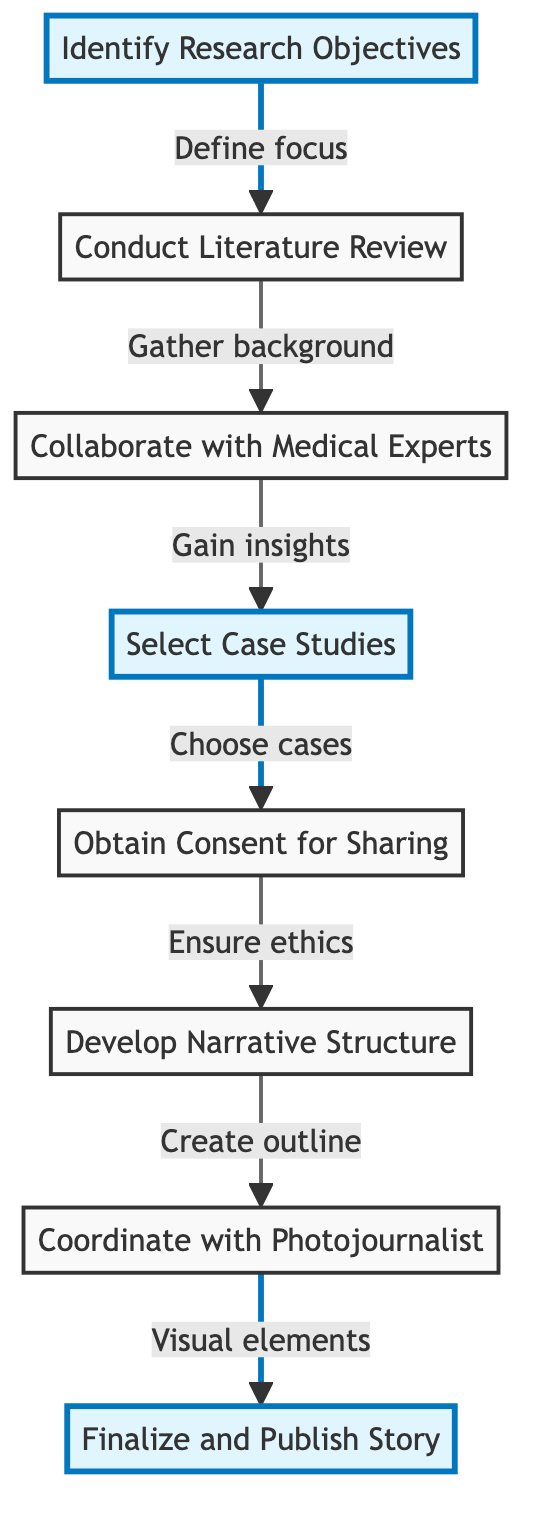What is the first step in the process? The first step in the process is "Identify Research Objectives," which is the starting point of the flowchart.
Answer: Identify Research Objectives How many nodes are highlighted in the diagram? There are three highlighted nodes in the diagram, which are "Identify Research Objectives," "Select Case Studies," and "Finalize and Publish Story."
Answer: Three What step follows after "Conduct Literature Review"? After "Conduct Literature Review," the next step is "Collaborate with Medical Experts," which illustrates the flow from reviewing literature to seeking expert insights.
Answer: Collaborate with Medical Experts What is required after selecting case studies? After selecting case studies, the next requirement is to "Obtain Consent for Sharing," which ensures ethical standards are met before sharing patient information.
Answer: Obtain Consent for Sharing Which step involves coordinating with the photojournalist? The step that involves coordinating with the photojournalist is "Coordinate with Photojournalist," which highlights collaboration in visual storytelling.
Answer: Coordinate with Photojournalist What theme is being developed after obtaining consent? After obtaining consent, the theme being developed is the "Develop Narrative Structure," where the outline and key themes for the narrative are created.
Answer: Develop Narrative Structure What is the link style between the nodes "Obtain Consent for Sharing" and "Develop Narrative Structure"? The link between "Obtain Consent for Sharing" and "Develop Narrative Structure" has a default style, which is a standard stroke width and color indicated in the diagram.
Answer: Default style What is the last step in the process? The last step in the process is "Finalize and Publish Story," marking the completion of the narrative creation and its release to the audience.
Answer: Finalize and Publish Story What role does "Collaborate with Medical Experts" serve in the research process? "Collaborate with Medical Experts" serves as an intermediary step to gather insights that inform the selection of appropriate case studies, bridging literature review and case selection.
Answer: Insight gathering step 